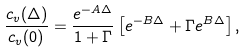Convert formula to latex. <formula><loc_0><loc_0><loc_500><loc_500>\frac { c _ { v } ( \Delta ) } { c _ { v } ( 0 ) } = \frac { e ^ { - A \Delta } } { 1 + \Gamma } \left [ e ^ { - B \Delta } + \Gamma e ^ { B \Delta } \right ] ,</formula> 